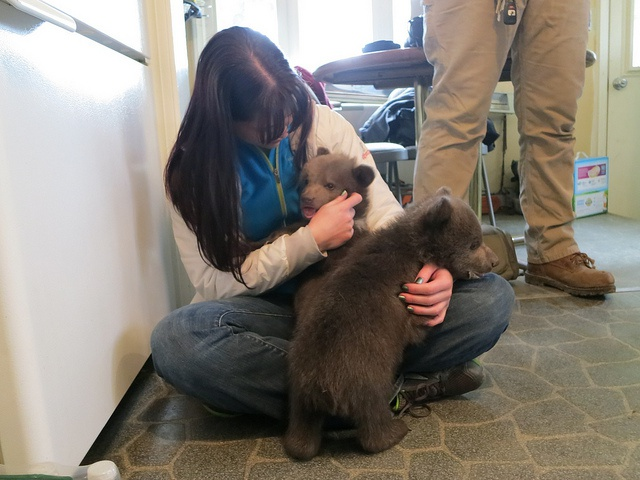Describe the objects in this image and their specific colors. I can see refrigerator in gray, lightgray, and darkgray tones, people in gray, black, navy, and darkgray tones, people in gray, tan, and darkgray tones, bear in gray, black, and maroon tones, and dining table in gray, darkgray, and darkblue tones in this image. 